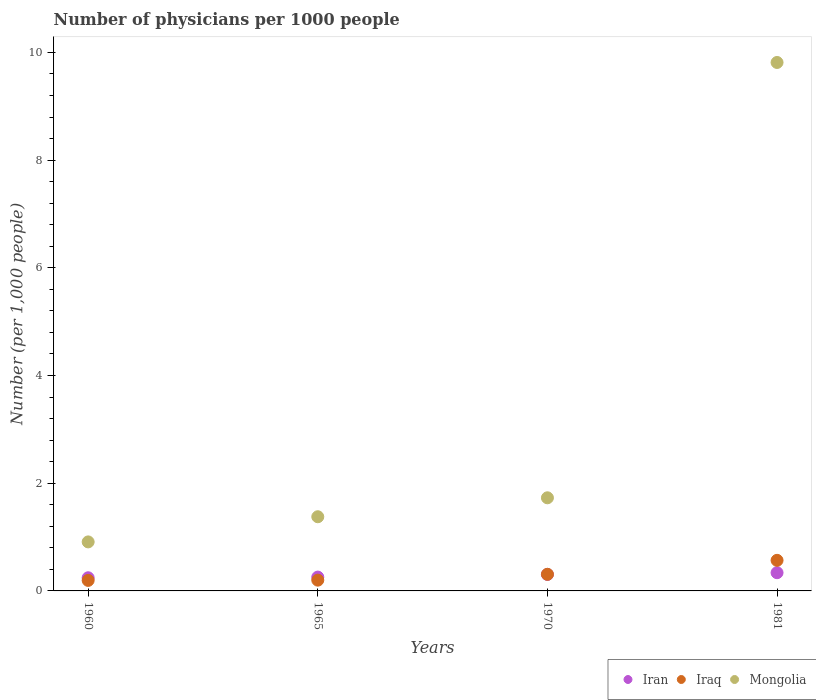How many different coloured dotlines are there?
Offer a terse response. 3. Is the number of dotlines equal to the number of legend labels?
Offer a terse response. Yes. What is the number of physicians in Mongolia in 1960?
Keep it short and to the point. 0.91. Across all years, what is the maximum number of physicians in Iran?
Provide a succinct answer. 0.34. Across all years, what is the minimum number of physicians in Mongolia?
Provide a short and direct response. 0.91. In which year was the number of physicians in Iraq minimum?
Your answer should be compact. 1960. What is the total number of physicians in Mongolia in the graph?
Your answer should be very brief. 13.83. What is the difference between the number of physicians in Iraq in 1970 and that in 1981?
Provide a short and direct response. -0.26. What is the difference between the number of physicians in Iraq in 1960 and the number of physicians in Mongolia in 1981?
Keep it short and to the point. -9.62. What is the average number of physicians in Iran per year?
Offer a terse response. 0.29. In the year 1970, what is the difference between the number of physicians in Iran and number of physicians in Mongolia?
Provide a short and direct response. -1.42. In how many years, is the number of physicians in Mongolia greater than 5.2?
Your answer should be very brief. 1. What is the ratio of the number of physicians in Iraq in 1960 to that in 1981?
Provide a short and direct response. 0.34. What is the difference between the highest and the second highest number of physicians in Iraq?
Provide a short and direct response. 0.26. What is the difference between the highest and the lowest number of physicians in Mongolia?
Your answer should be very brief. 8.9. In how many years, is the number of physicians in Iran greater than the average number of physicians in Iran taken over all years?
Provide a short and direct response. 2. Is it the case that in every year, the sum of the number of physicians in Mongolia and number of physicians in Iraq  is greater than the number of physicians in Iran?
Provide a succinct answer. Yes. Is the number of physicians in Iran strictly greater than the number of physicians in Iraq over the years?
Offer a very short reply. No. Is the number of physicians in Iran strictly less than the number of physicians in Mongolia over the years?
Offer a very short reply. Yes. How many dotlines are there?
Offer a very short reply. 3. Are the values on the major ticks of Y-axis written in scientific E-notation?
Make the answer very short. No. Where does the legend appear in the graph?
Keep it short and to the point. Bottom right. What is the title of the graph?
Your answer should be compact. Number of physicians per 1000 people. What is the label or title of the Y-axis?
Provide a succinct answer. Number (per 1,0 people). What is the Number (per 1,000 people) of Iran in 1960?
Offer a terse response. 0.24. What is the Number (per 1,000 people) of Iraq in 1960?
Ensure brevity in your answer.  0.2. What is the Number (per 1,000 people) of Mongolia in 1960?
Keep it short and to the point. 0.91. What is the Number (per 1,000 people) in Iran in 1965?
Your answer should be very brief. 0.26. What is the Number (per 1,000 people) in Iraq in 1965?
Ensure brevity in your answer.  0.2. What is the Number (per 1,000 people) of Mongolia in 1965?
Your answer should be compact. 1.38. What is the Number (per 1,000 people) in Iran in 1970?
Give a very brief answer. 0.31. What is the Number (per 1,000 people) in Iraq in 1970?
Offer a terse response. 0.31. What is the Number (per 1,000 people) of Mongolia in 1970?
Your answer should be compact. 1.73. What is the Number (per 1,000 people) of Iran in 1981?
Ensure brevity in your answer.  0.34. What is the Number (per 1,000 people) in Iraq in 1981?
Offer a very short reply. 0.57. What is the Number (per 1,000 people) of Mongolia in 1981?
Provide a short and direct response. 9.81. Across all years, what is the maximum Number (per 1,000 people) of Iran?
Give a very brief answer. 0.34. Across all years, what is the maximum Number (per 1,000 people) in Iraq?
Your answer should be compact. 0.57. Across all years, what is the maximum Number (per 1,000 people) of Mongolia?
Your answer should be compact. 9.81. Across all years, what is the minimum Number (per 1,000 people) in Iran?
Your answer should be compact. 0.24. Across all years, what is the minimum Number (per 1,000 people) in Iraq?
Give a very brief answer. 0.2. Across all years, what is the minimum Number (per 1,000 people) in Mongolia?
Offer a very short reply. 0.91. What is the total Number (per 1,000 people) of Iran in the graph?
Offer a terse response. 1.15. What is the total Number (per 1,000 people) of Iraq in the graph?
Provide a succinct answer. 1.27. What is the total Number (per 1,000 people) in Mongolia in the graph?
Ensure brevity in your answer.  13.83. What is the difference between the Number (per 1,000 people) in Iran in 1960 and that in 1965?
Provide a succinct answer. -0.01. What is the difference between the Number (per 1,000 people) of Iraq in 1960 and that in 1965?
Offer a very short reply. -0. What is the difference between the Number (per 1,000 people) of Mongolia in 1960 and that in 1965?
Give a very brief answer. -0.47. What is the difference between the Number (per 1,000 people) in Iran in 1960 and that in 1970?
Keep it short and to the point. -0.06. What is the difference between the Number (per 1,000 people) in Iraq in 1960 and that in 1970?
Give a very brief answer. -0.11. What is the difference between the Number (per 1,000 people) in Mongolia in 1960 and that in 1970?
Make the answer very short. -0.82. What is the difference between the Number (per 1,000 people) of Iran in 1960 and that in 1981?
Give a very brief answer. -0.09. What is the difference between the Number (per 1,000 people) of Iraq in 1960 and that in 1981?
Your response must be concise. -0.37. What is the difference between the Number (per 1,000 people) of Mongolia in 1960 and that in 1981?
Ensure brevity in your answer.  -8.9. What is the difference between the Number (per 1,000 people) of Iran in 1965 and that in 1970?
Your response must be concise. -0.05. What is the difference between the Number (per 1,000 people) of Iraq in 1965 and that in 1970?
Your response must be concise. -0.11. What is the difference between the Number (per 1,000 people) of Mongolia in 1965 and that in 1970?
Provide a succinct answer. -0.35. What is the difference between the Number (per 1,000 people) in Iran in 1965 and that in 1981?
Provide a succinct answer. -0.08. What is the difference between the Number (per 1,000 people) in Iraq in 1965 and that in 1981?
Provide a succinct answer. -0.37. What is the difference between the Number (per 1,000 people) of Mongolia in 1965 and that in 1981?
Your answer should be very brief. -8.44. What is the difference between the Number (per 1,000 people) of Iran in 1970 and that in 1981?
Offer a terse response. -0.03. What is the difference between the Number (per 1,000 people) of Iraq in 1970 and that in 1981?
Provide a succinct answer. -0.26. What is the difference between the Number (per 1,000 people) in Mongolia in 1970 and that in 1981?
Provide a succinct answer. -8.08. What is the difference between the Number (per 1,000 people) in Iran in 1960 and the Number (per 1,000 people) in Iraq in 1965?
Offer a terse response. 0.04. What is the difference between the Number (per 1,000 people) of Iran in 1960 and the Number (per 1,000 people) of Mongolia in 1965?
Offer a very short reply. -1.13. What is the difference between the Number (per 1,000 people) in Iraq in 1960 and the Number (per 1,000 people) in Mongolia in 1965?
Ensure brevity in your answer.  -1.18. What is the difference between the Number (per 1,000 people) in Iran in 1960 and the Number (per 1,000 people) in Iraq in 1970?
Give a very brief answer. -0.06. What is the difference between the Number (per 1,000 people) in Iran in 1960 and the Number (per 1,000 people) in Mongolia in 1970?
Offer a very short reply. -1.49. What is the difference between the Number (per 1,000 people) of Iraq in 1960 and the Number (per 1,000 people) of Mongolia in 1970?
Make the answer very short. -1.53. What is the difference between the Number (per 1,000 people) in Iran in 1960 and the Number (per 1,000 people) in Iraq in 1981?
Provide a succinct answer. -0.32. What is the difference between the Number (per 1,000 people) in Iran in 1960 and the Number (per 1,000 people) in Mongolia in 1981?
Provide a succinct answer. -9.57. What is the difference between the Number (per 1,000 people) in Iraq in 1960 and the Number (per 1,000 people) in Mongolia in 1981?
Ensure brevity in your answer.  -9.62. What is the difference between the Number (per 1,000 people) of Iran in 1965 and the Number (per 1,000 people) of Iraq in 1970?
Your response must be concise. -0.05. What is the difference between the Number (per 1,000 people) of Iran in 1965 and the Number (per 1,000 people) of Mongolia in 1970?
Your response must be concise. -1.47. What is the difference between the Number (per 1,000 people) of Iraq in 1965 and the Number (per 1,000 people) of Mongolia in 1970?
Keep it short and to the point. -1.53. What is the difference between the Number (per 1,000 people) of Iran in 1965 and the Number (per 1,000 people) of Iraq in 1981?
Your answer should be compact. -0.31. What is the difference between the Number (per 1,000 people) of Iran in 1965 and the Number (per 1,000 people) of Mongolia in 1981?
Provide a succinct answer. -9.56. What is the difference between the Number (per 1,000 people) of Iraq in 1965 and the Number (per 1,000 people) of Mongolia in 1981?
Give a very brief answer. -9.61. What is the difference between the Number (per 1,000 people) in Iran in 1970 and the Number (per 1,000 people) in Iraq in 1981?
Offer a very short reply. -0.26. What is the difference between the Number (per 1,000 people) in Iran in 1970 and the Number (per 1,000 people) in Mongolia in 1981?
Ensure brevity in your answer.  -9.51. What is the difference between the Number (per 1,000 people) in Iraq in 1970 and the Number (per 1,000 people) in Mongolia in 1981?
Make the answer very short. -9.51. What is the average Number (per 1,000 people) of Iran per year?
Your response must be concise. 0.29. What is the average Number (per 1,000 people) of Iraq per year?
Ensure brevity in your answer.  0.32. What is the average Number (per 1,000 people) in Mongolia per year?
Offer a very short reply. 3.46. In the year 1960, what is the difference between the Number (per 1,000 people) in Iran and Number (per 1,000 people) in Iraq?
Offer a very short reply. 0.05. In the year 1960, what is the difference between the Number (per 1,000 people) of Iran and Number (per 1,000 people) of Mongolia?
Keep it short and to the point. -0.67. In the year 1960, what is the difference between the Number (per 1,000 people) of Iraq and Number (per 1,000 people) of Mongolia?
Offer a terse response. -0.71. In the year 1965, what is the difference between the Number (per 1,000 people) in Iran and Number (per 1,000 people) in Iraq?
Your answer should be compact. 0.06. In the year 1965, what is the difference between the Number (per 1,000 people) of Iran and Number (per 1,000 people) of Mongolia?
Keep it short and to the point. -1.12. In the year 1965, what is the difference between the Number (per 1,000 people) in Iraq and Number (per 1,000 people) in Mongolia?
Provide a short and direct response. -1.18. In the year 1970, what is the difference between the Number (per 1,000 people) of Iran and Number (per 1,000 people) of Iraq?
Provide a short and direct response. -0. In the year 1970, what is the difference between the Number (per 1,000 people) of Iran and Number (per 1,000 people) of Mongolia?
Ensure brevity in your answer.  -1.42. In the year 1970, what is the difference between the Number (per 1,000 people) of Iraq and Number (per 1,000 people) of Mongolia?
Make the answer very short. -1.42. In the year 1981, what is the difference between the Number (per 1,000 people) of Iran and Number (per 1,000 people) of Iraq?
Ensure brevity in your answer.  -0.23. In the year 1981, what is the difference between the Number (per 1,000 people) in Iran and Number (per 1,000 people) in Mongolia?
Keep it short and to the point. -9.48. In the year 1981, what is the difference between the Number (per 1,000 people) in Iraq and Number (per 1,000 people) in Mongolia?
Offer a terse response. -9.25. What is the ratio of the Number (per 1,000 people) of Iran in 1960 to that in 1965?
Your answer should be compact. 0.95. What is the ratio of the Number (per 1,000 people) of Iraq in 1960 to that in 1965?
Make the answer very short. 0.98. What is the ratio of the Number (per 1,000 people) of Mongolia in 1960 to that in 1965?
Provide a short and direct response. 0.66. What is the ratio of the Number (per 1,000 people) of Iran in 1960 to that in 1970?
Your answer should be compact. 0.8. What is the ratio of the Number (per 1,000 people) in Iraq in 1960 to that in 1970?
Offer a very short reply. 0.63. What is the ratio of the Number (per 1,000 people) in Mongolia in 1960 to that in 1970?
Make the answer very short. 0.53. What is the ratio of the Number (per 1,000 people) in Iran in 1960 to that in 1981?
Keep it short and to the point. 0.72. What is the ratio of the Number (per 1,000 people) of Iraq in 1960 to that in 1981?
Make the answer very short. 0.34. What is the ratio of the Number (per 1,000 people) of Mongolia in 1960 to that in 1981?
Your answer should be compact. 0.09. What is the ratio of the Number (per 1,000 people) in Iran in 1965 to that in 1970?
Provide a succinct answer. 0.84. What is the ratio of the Number (per 1,000 people) of Iraq in 1965 to that in 1970?
Offer a terse response. 0.65. What is the ratio of the Number (per 1,000 people) in Mongolia in 1965 to that in 1970?
Make the answer very short. 0.8. What is the ratio of the Number (per 1,000 people) of Iran in 1965 to that in 1981?
Your response must be concise. 0.76. What is the ratio of the Number (per 1,000 people) of Iraq in 1965 to that in 1981?
Your answer should be very brief. 0.35. What is the ratio of the Number (per 1,000 people) in Mongolia in 1965 to that in 1981?
Your response must be concise. 0.14. What is the ratio of the Number (per 1,000 people) in Iran in 1970 to that in 1981?
Ensure brevity in your answer.  0.9. What is the ratio of the Number (per 1,000 people) in Iraq in 1970 to that in 1981?
Your answer should be compact. 0.54. What is the ratio of the Number (per 1,000 people) of Mongolia in 1970 to that in 1981?
Provide a short and direct response. 0.18. What is the difference between the highest and the second highest Number (per 1,000 people) of Iran?
Offer a terse response. 0.03. What is the difference between the highest and the second highest Number (per 1,000 people) of Iraq?
Your answer should be very brief. 0.26. What is the difference between the highest and the second highest Number (per 1,000 people) of Mongolia?
Your response must be concise. 8.08. What is the difference between the highest and the lowest Number (per 1,000 people) in Iran?
Offer a terse response. 0.09. What is the difference between the highest and the lowest Number (per 1,000 people) in Iraq?
Your answer should be very brief. 0.37. What is the difference between the highest and the lowest Number (per 1,000 people) of Mongolia?
Your response must be concise. 8.9. 